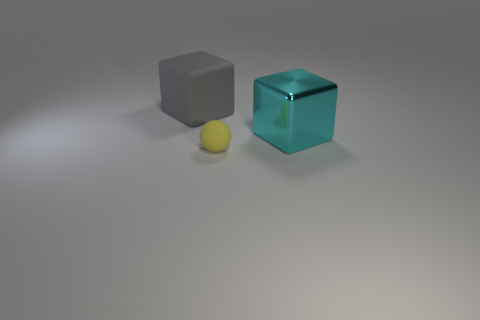There is another big object that is the same shape as the gray object; what is its material?
Make the answer very short. Metal. Is there anything else that has the same size as the yellow thing?
Provide a succinct answer. No. There is a rubber thing behind the cyan thing; is it the same shape as the large thing that is to the right of the small rubber object?
Make the answer very short. Yes. Are there fewer small things that are behind the big cyan object than things that are behind the yellow rubber sphere?
Your answer should be very brief. Yes. What number of other objects are there of the same shape as the tiny yellow thing?
Offer a terse response. 0. What shape is the other object that is the same material as the yellow thing?
Your answer should be very brief. Cube. The object that is in front of the big matte object and behind the rubber sphere is what color?
Give a very brief answer. Cyan. Do the block behind the large cyan thing and the tiny thing have the same material?
Your answer should be compact. Yes. Is the number of small objects on the right side of the yellow rubber thing less than the number of metal cubes?
Keep it short and to the point. Yes. Are there any gray objects made of the same material as the yellow sphere?
Offer a very short reply. Yes. 